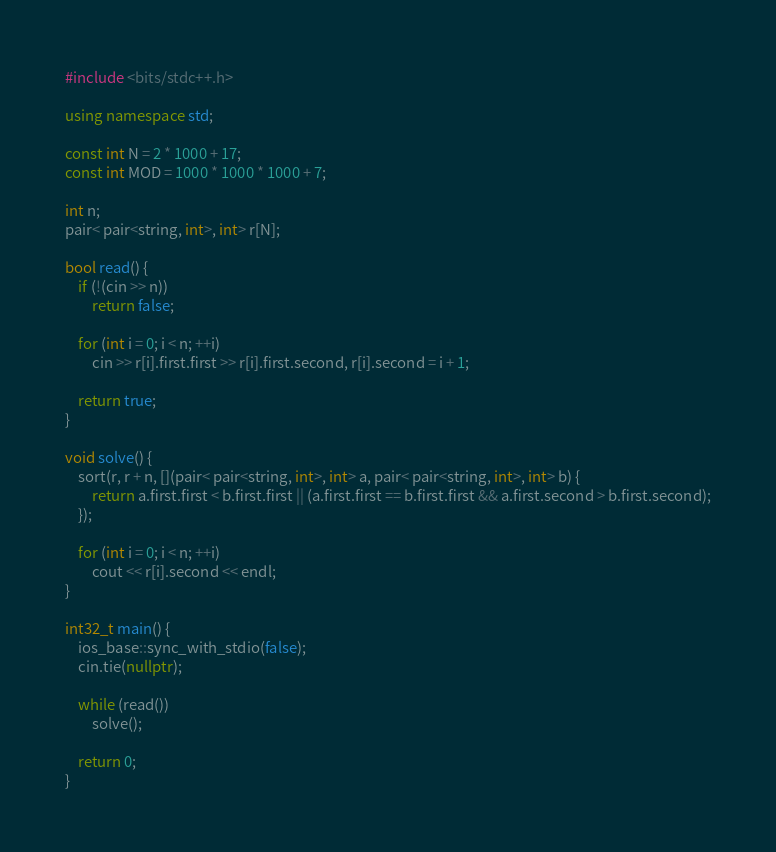Convert code to text. <code><loc_0><loc_0><loc_500><loc_500><_C++_>#include <bits/stdc++.h>

using namespace std;

const int N = 2 * 1000 + 17;
const int MOD = 1000 * 1000 * 1000 + 7;

int n;
pair< pair<string, int>, int> r[N];

bool read() {
    if (!(cin >> n))
        return false;

    for (int i = 0; i < n; ++i)
        cin >> r[i].first.first >> r[i].first.second, r[i].second = i + 1;

    return true;
}

void solve() {
    sort(r, r + n, [](pair< pair<string, int>, int> a, pair< pair<string, int>, int> b) {
        return a.first.first < b.first.first || (a.first.first == b.first.first && a.first.second > b.first.second);
    });

    for (int i = 0; i < n; ++i)
        cout << r[i].second << endl;
}

int32_t main() {
    ios_base::sync_with_stdio(false);
    cin.tie(nullptr);

    while (read())
        solve();

    return 0;
}

</code> 